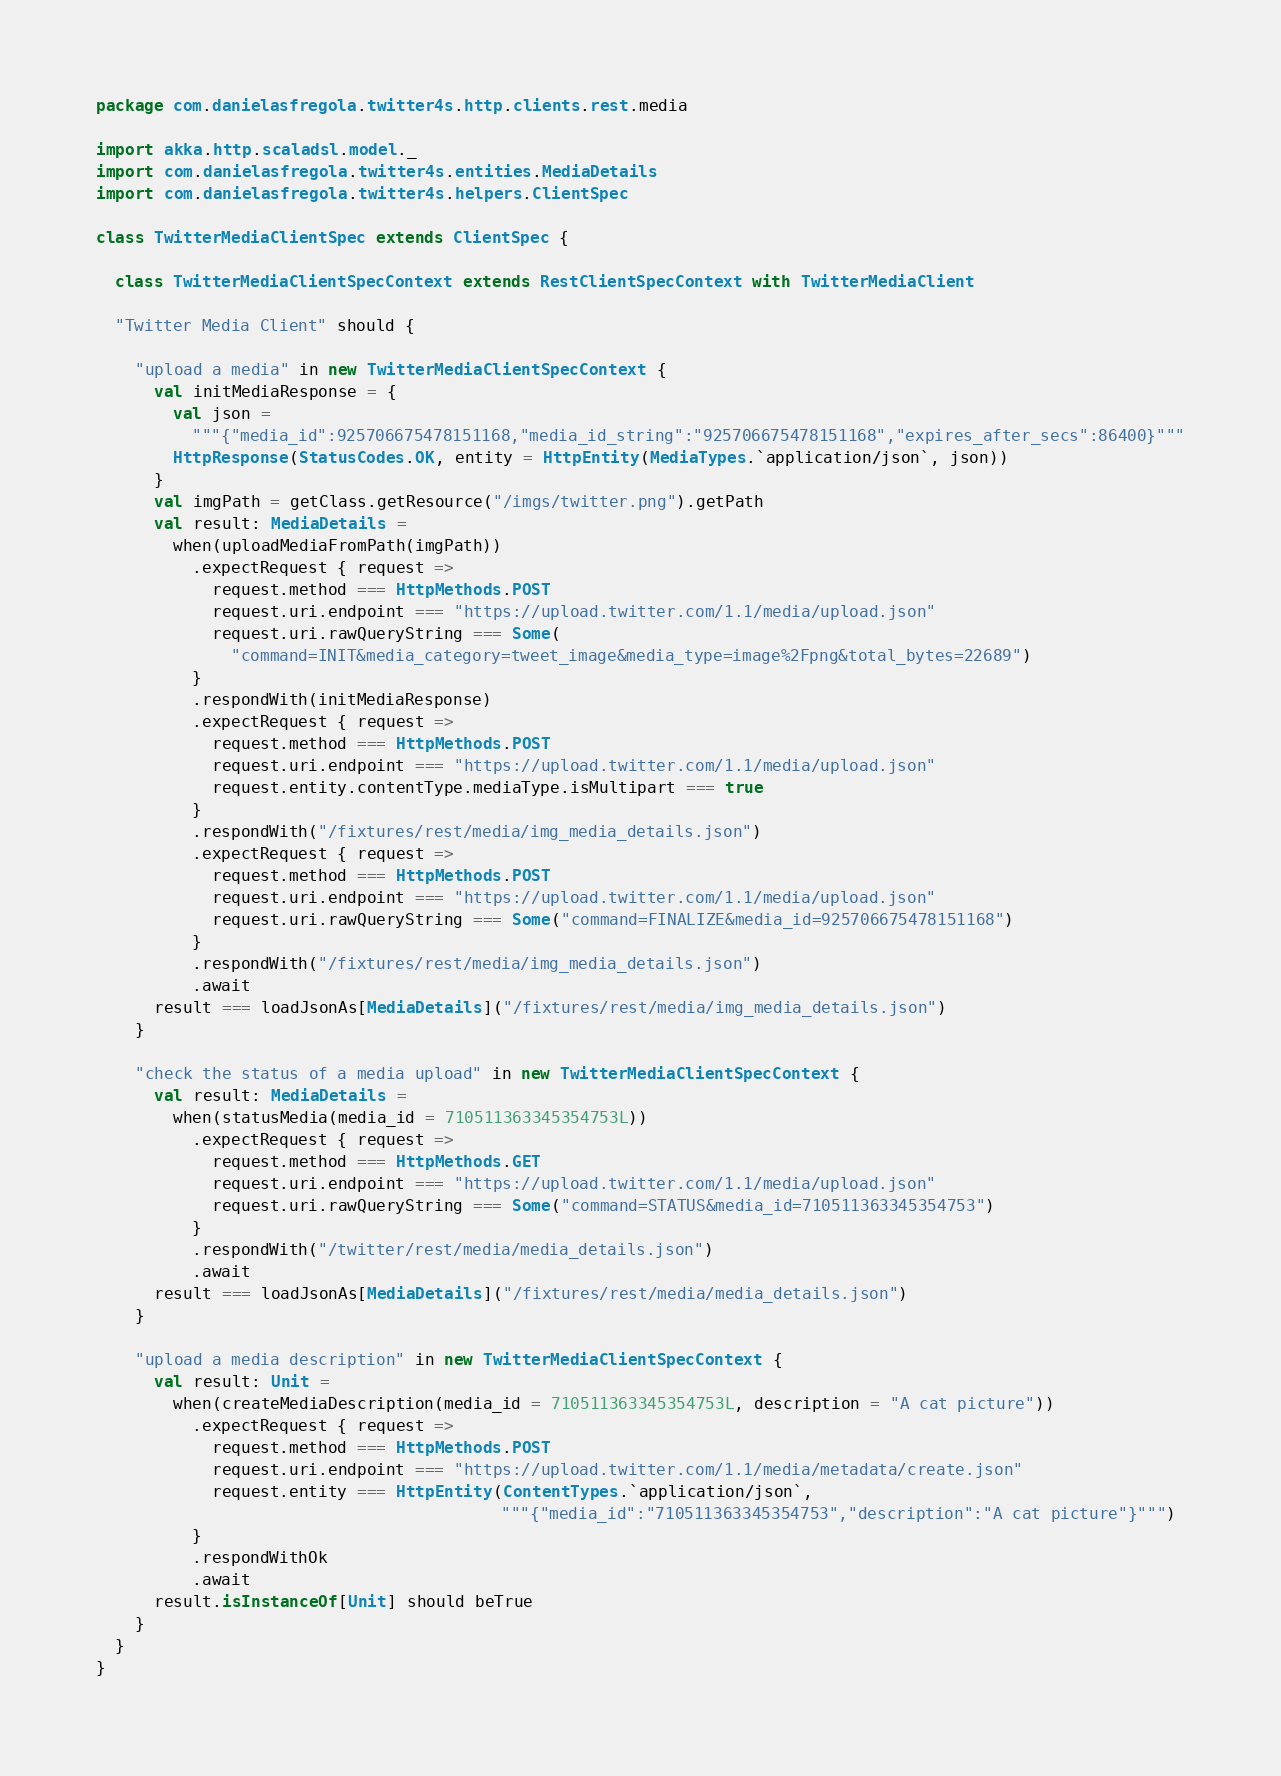Convert code to text. <code><loc_0><loc_0><loc_500><loc_500><_Scala_>package com.danielasfregola.twitter4s.http.clients.rest.media

import akka.http.scaladsl.model._
import com.danielasfregola.twitter4s.entities.MediaDetails
import com.danielasfregola.twitter4s.helpers.ClientSpec

class TwitterMediaClientSpec extends ClientSpec {

  class TwitterMediaClientSpecContext extends RestClientSpecContext with TwitterMediaClient

  "Twitter Media Client" should {

    "upload a media" in new TwitterMediaClientSpecContext {
      val initMediaResponse = {
        val json =
          """{"media_id":925706675478151168,"media_id_string":"925706675478151168","expires_after_secs":86400}"""
        HttpResponse(StatusCodes.OK, entity = HttpEntity(MediaTypes.`application/json`, json))
      }
      val imgPath = getClass.getResource("/imgs/twitter.png").getPath
      val result: MediaDetails =
        when(uploadMediaFromPath(imgPath))
          .expectRequest { request =>
            request.method === HttpMethods.POST
            request.uri.endpoint === "https://upload.twitter.com/1.1/media/upload.json"
            request.uri.rawQueryString === Some(
              "command=INIT&media_category=tweet_image&media_type=image%2Fpng&total_bytes=22689")
          }
          .respondWith(initMediaResponse)
          .expectRequest { request =>
            request.method === HttpMethods.POST
            request.uri.endpoint === "https://upload.twitter.com/1.1/media/upload.json"
            request.entity.contentType.mediaType.isMultipart === true
          }
          .respondWith("/fixtures/rest/media/img_media_details.json")
          .expectRequest { request =>
            request.method === HttpMethods.POST
            request.uri.endpoint === "https://upload.twitter.com/1.1/media/upload.json"
            request.uri.rawQueryString === Some("command=FINALIZE&media_id=925706675478151168")
          }
          .respondWith("/fixtures/rest/media/img_media_details.json")
          .await
      result === loadJsonAs[MediaDetails]("/fixtures/rest/media/img_media_details.json")
    }

    "check the status of a media upload" in new TwitterMediaClientSpecContext {
      val result: MediaDetails =
        when(statusMedia(media_id = 710511363345354753L))
          .expectRequest { request =>
            request.method === HttpMethods.GET
            request.uri.endpoint === "https://upload.twitter.com/1.1/media/upload.json"
            request.uri.rawQueryString === Some("command=STATUS&media_id=710511363345354753")
          }
          .respondWith("/twitter/rest/media/media_details.json")
          .await
      result === loadJsonAs[MediaDetails]("/fixtures/rest/media/media_details.json")
    }

    "upload a media description" in new TwitterMediaClientSpecContext {
      val result: Unit =
        when(createMediaDescription(media_id = 710511363345354753L, description = "A cat picture"))
          .expectRequest { request =>
            request.method === HttpMethods.POST
            request.uri.endpoint === "https://upload.twitter.com/1.1/media/metadata/create.json"
            request.entity === HttpEntity(ContentTypes.`application/json`,
                                          """{"media_id":"710511363345354753","description":"A cat picture"}""")
          }
          .respondWithOk
          .await
      result.isInstanceOf[Unit] should beTrue
    }
  }
}
</code> 